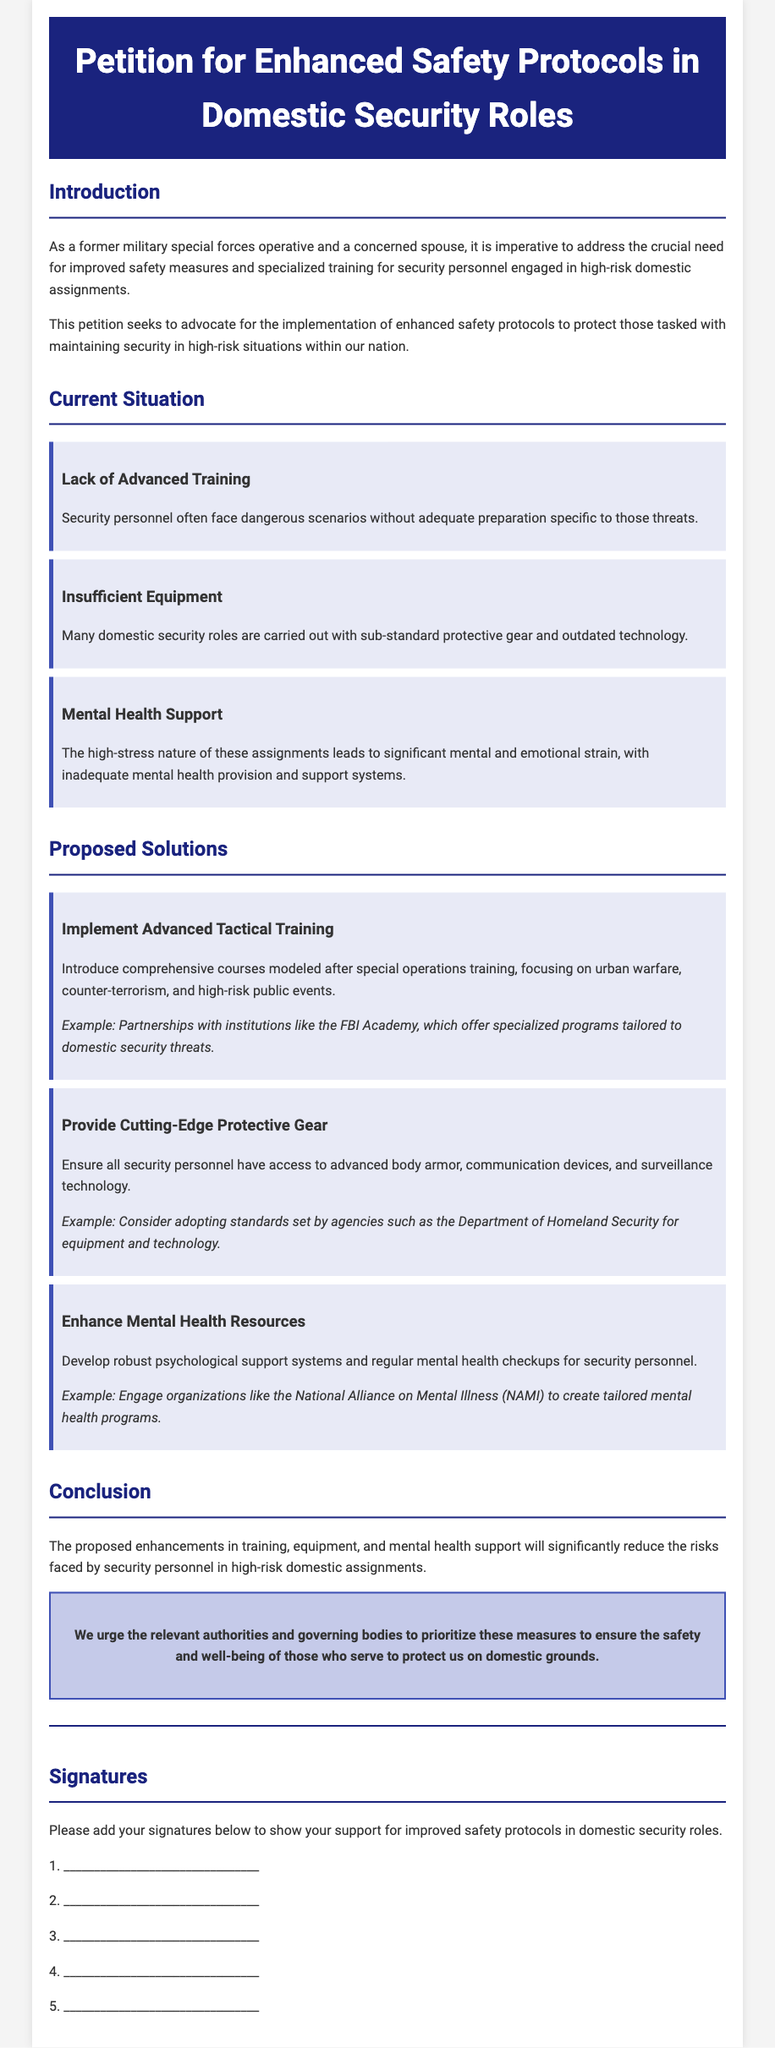What is the title of the petition? The title clearly states the purpose of the document.
Answer: Petition for Enhanced Safety Protocols in Domestic Security Roles What is one reason for the current situation highlighted in the petition? The petition lists several issues, one of which pertains to training.
Answer: Lack of Advanced Training What organization is mentioned for potential partnerships regarding training? The document specifies an organization associated with training.
Answer: FBI Academy What type of gear is proposed to be provided to security personnel? The petition emphasizes improvements in protective equipment.
Answer: Cutting-Edge Protective Gear What is one proposed solution for mental health support? The petition suggests a specific type of support for security personnel.
Answer: Enhance Mental Health Resources How many proposals are listed in the document? The section outlines several distinct proposals for improvement.
Answer: Three What color is the header background? This is a simple question about the visual design of the document.
Answer: Dark blue What is the purpose of the call-to-action section? It highlights the need for urgent changes and actions.
Answer: To ensure the safety and well-being of those who serve How are signatures collected in the document? The section details a specific method for showing support.
Answer: Please add your signatures below What does this petition advocate for? The main goal of the petition is clearly defined.
Answer: Enhanced safety protocols 